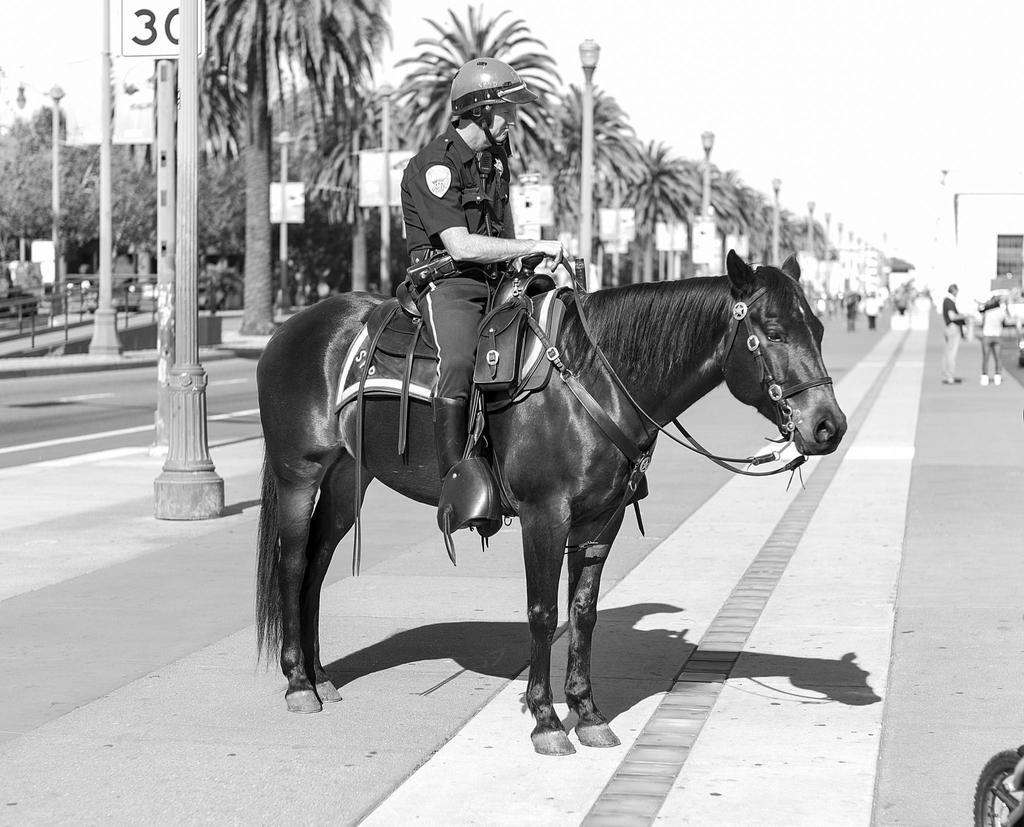What is the main subject of the image? There is a person sitting on a horse in the image. What can be seen on the left side of the image? There are trees on the left side of the image. What is visible at the top of the image? The sky is visible at the top of the image. Are there any dinosaurs playing a game near the nest in the image? There are no dinosaurs or nests present in the image; it features a person sitting on a horse with trees and the sky visible. 